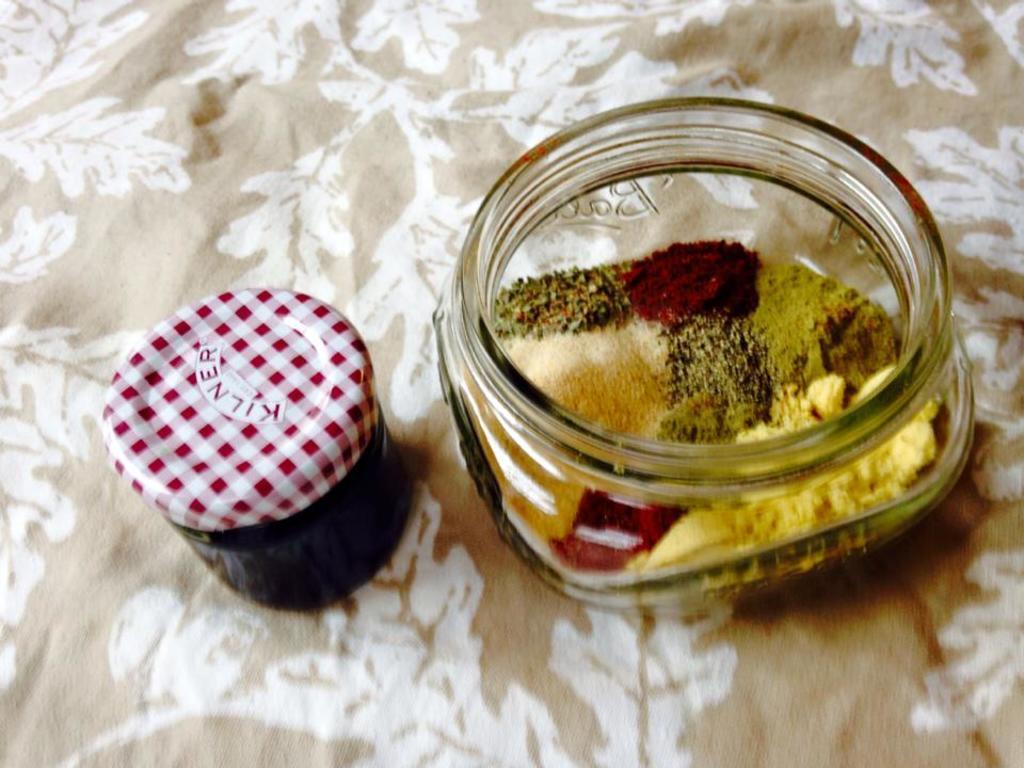Can you describe this image briefly? In this image there are two jars with food items in it on a table. 